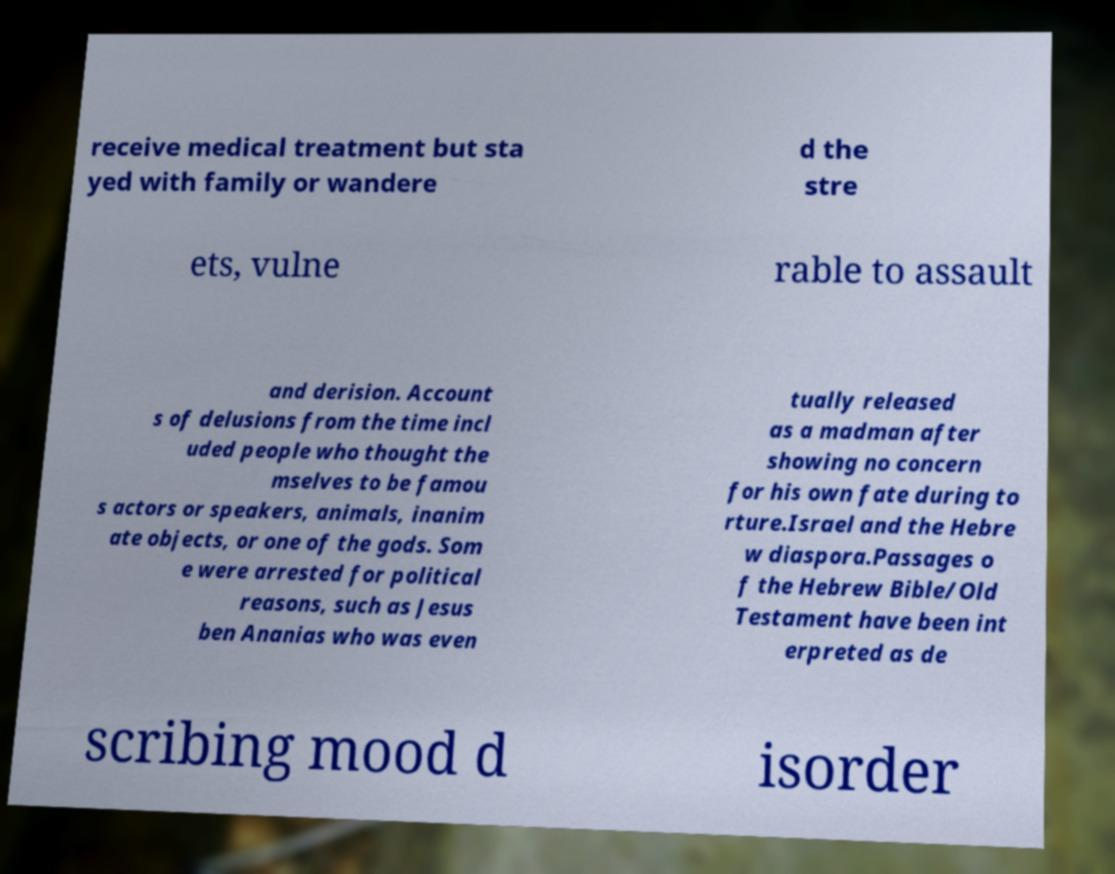There's text embedded in this image that I need extracted. Can you transcribe it verbatim? receive medical treatment but sta yed with family or wandere d the stre ets, vulne rable to assault and derision. Account s of delusions from the time incl uded people who thought the mselves to be famou s actors or speakers, animals, inanim ate objects, or one of the gods. Som e were arrested for political reasons, such as Jesus ben Ananias who was even tually released as a madman after showing no concern for his own fate during to rture.Israel and the Hebre w diaspora.Passages o f the Hebrew Bible/Old Testament have been int erpreted as de scribing mood d isorder 